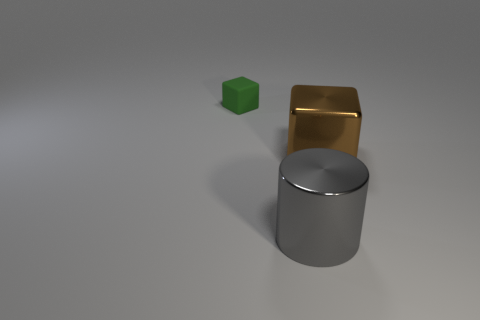Subtract all green cubes. How many cubes are left? 1 Subtract all cylinders. How many objects are left? 2 Subtract 2 cubes. How many cubes are left? 0 Subtract all metal cubes. Subtract all brown metallic cubes. How many objects are left? 1 Add 1 gray cylinders. How many gray cylinders are left? 2 Add 1 big shiny things. How many big shiny things exist? 3 Add 2 green rubber things. How many objects exist? 5 Subtract 0 red cylinders. How many objects are left? 3 Subtract all yellow blocks. Subtract all blue cylinders. How many blocks are left? 2 Subtract all cyan balls. How many green cubes are left? 1 